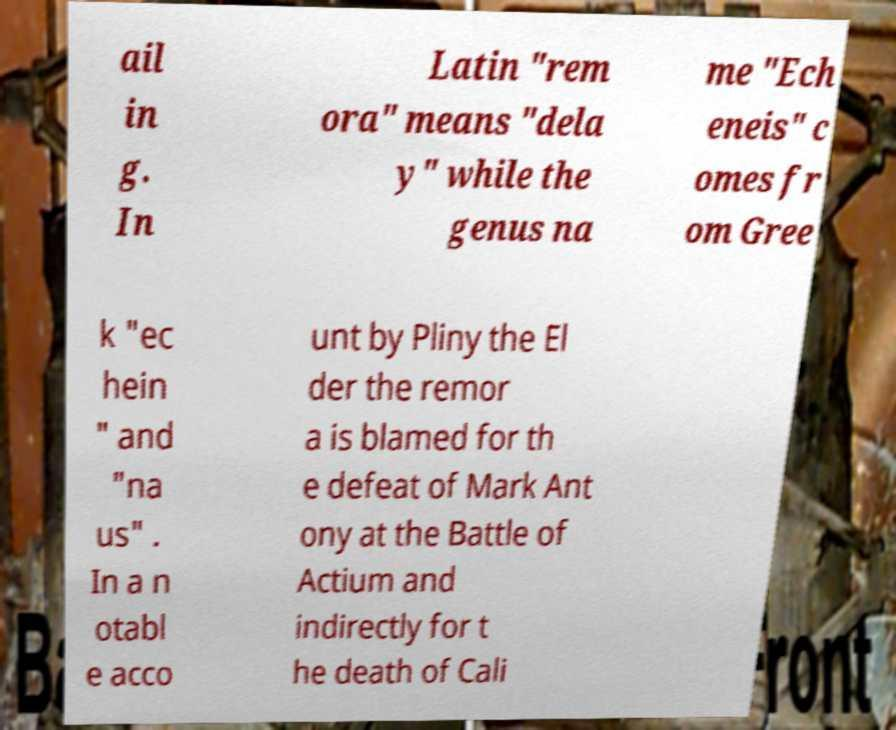There's text embedded in this image that I need extracted. Can you transcribe it verbatim? ail in g. In Latin "rem ora" means "dela y" while the genus na me "Ech eneis" c omes fr om Gree k "ec hein " and "na us" . In a n otabl e acco unt by Pliny the El der the remor a is blamed for th e defeat of Mark Ant ony at the Battle of Actium and indirectly for t he death of Cali 